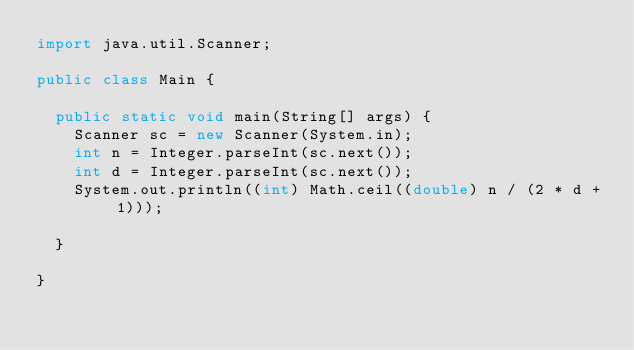<code> <loc_0><loc_0><loc_500><loc_500><_Java_>import java.util.Scanner;

public class Main {

	public static void main(String[] args) {
		Scanner sc = new Scanner(System.in);
		int n = Integer.parseInt(sc.next());
		int d = Integer.parseInt(sc.next());
		System.out.println((int) Math.ceil((double) n / (2 * d + 1)));

	}

}
</code> 